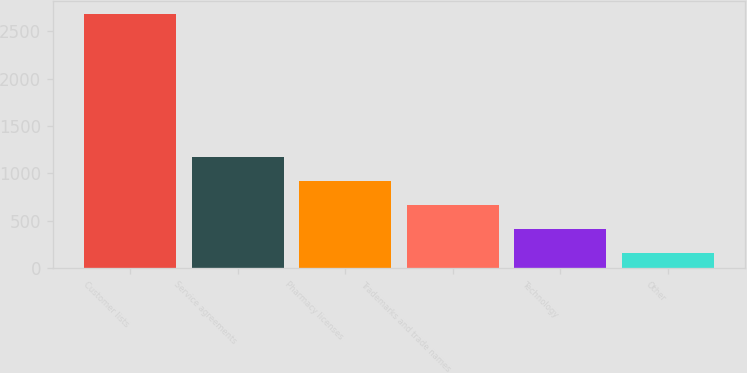Convert chart. <chart><loc_0><loc_0><loc_500><loc_500><bar_chart><fcel>Customer lists<fcel>Service agreements<fcel>Pharmacy licenses<fcel>Trademarks and trade names<fcel>Technology<fcel>Other<nl><fcel>2683<fcel>1170.4<fcel>918.3<fcel>666.2<fcel>414.1<fcel>162<nl></chart> 